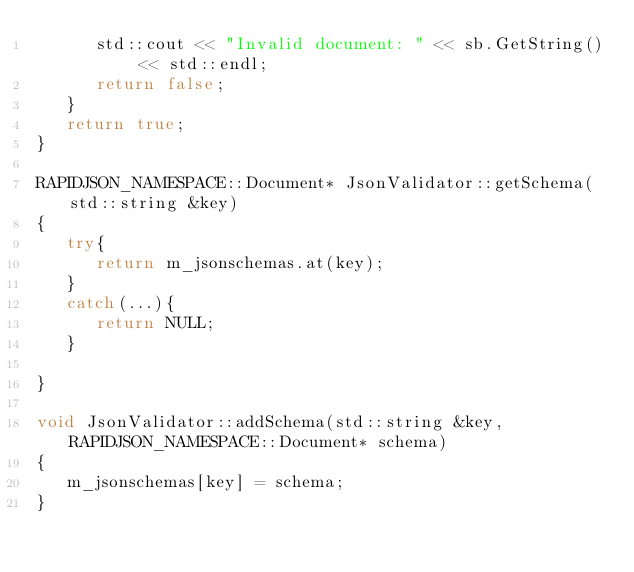<code> <loc_0><loc_0><loc_500><loc_500><_C++_>      std::cout << "Invalid document: " << sb.GetString() << std::endl;
      return false;
   }
   return true;
}

RAPIDJSON_NAMESPACE::Document* JsonValidator::getSchema(std::string &key)
{
   try{
      return m_jsonschemas.at(key);
   }
   catch(...){
      return NULL;
   }

}

void JsonValidator::addSchema(std::string &key, RAPIDJSON_NAMESPACE::Document* schema)
{
   m_jsonschemas[key] = schema;
}
</code> 